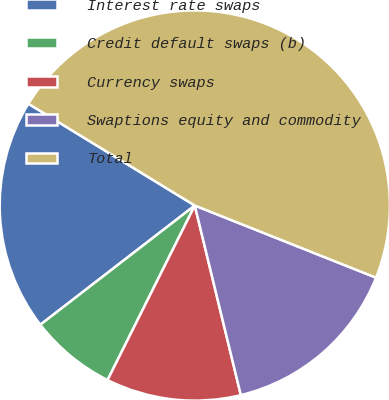Convert chart to OTSL. <chart><loc_0><loc_0><loc_500><loc_500><pie_chart><fcel>Interest rate swaps<fcel>Credit default swaps (b)<fcel>Currency swaps<fcel>Swaptions equity and commodity<fcel>Total<nl><fcel>19.2%<fcel>7.16%<fcel>11.17%<fcel>15.18%<fcel>47.29%<nl></chart> 